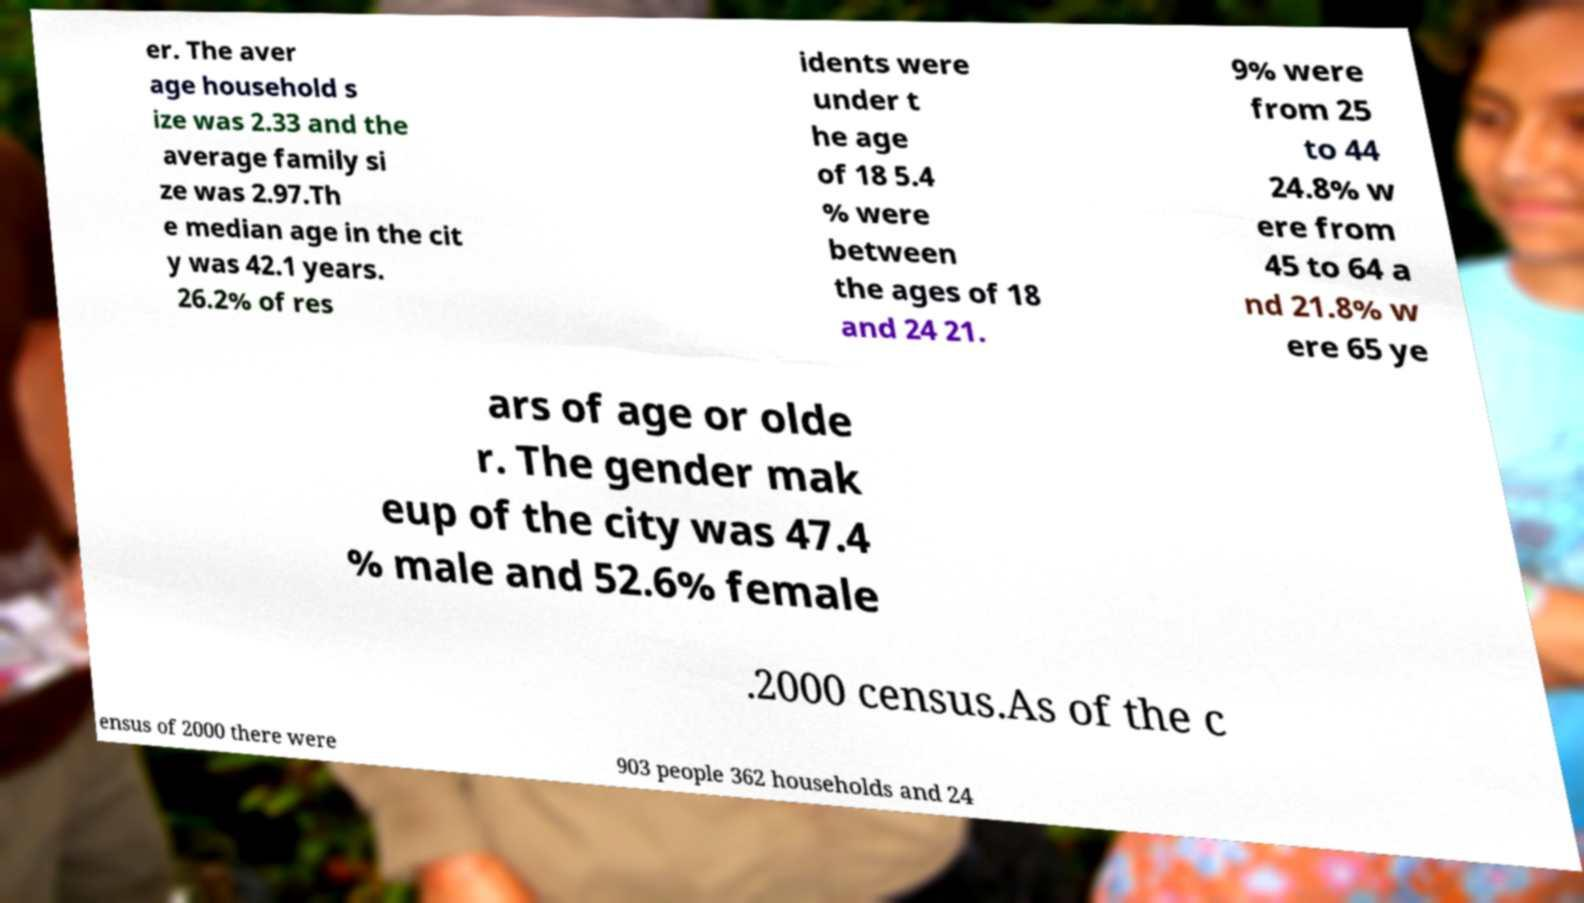Please identify and transcribe the text found in this image. er. The aver age household s ize was 2.33 and the average family si ze was 2.97.Th e median age in the cit y was 42.1 years. 26.2% of res idents were under t he age of 18 5.4 % were between the ages of 18 and 24 21. 9% were from 25 to 44 24.8% w ere from 45 to 64 a nd 21.8% w ere 65 ye ars of age or olde r. The gender mak eup of the city was 47.4 % male and 52.6% female .2000 census.As of the c ensus of 2000 there were 903 people 362 households and 24 